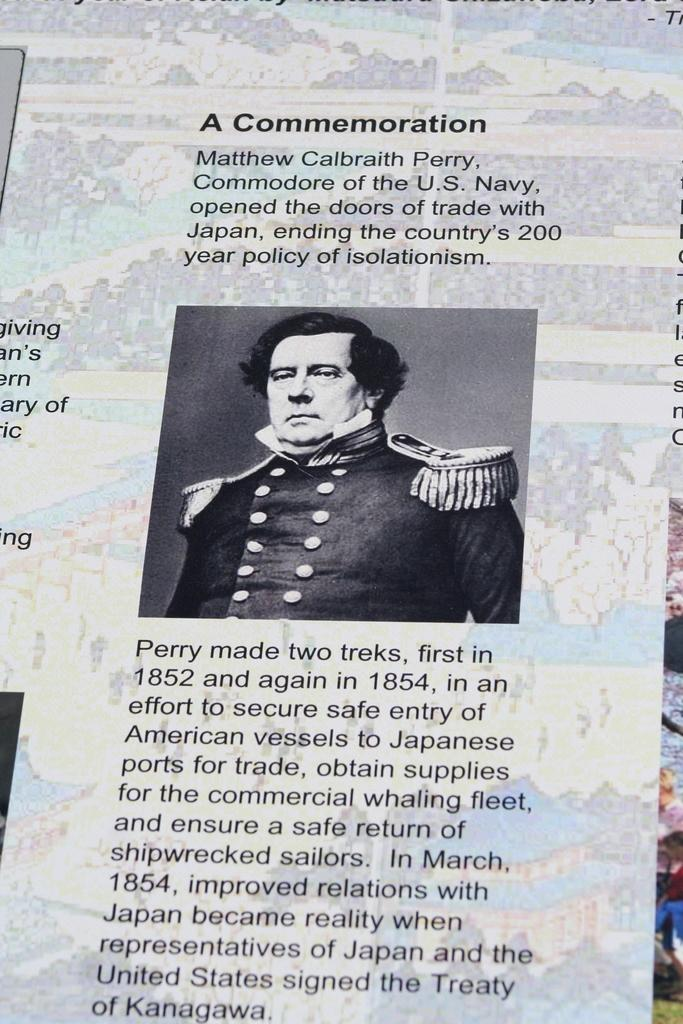What is featured on the poster in the image? There is a poster in the image, and it contains a picture of a man. What else is present on the poster besides the image? There is text on the poster. What type of powder is being used to draw the man on the poster? There is no indication in the image that any powder was used to create the poster. What type of cord is attached to the poster in the image? There is no cord visible in the image; the poster is simply displayed. 